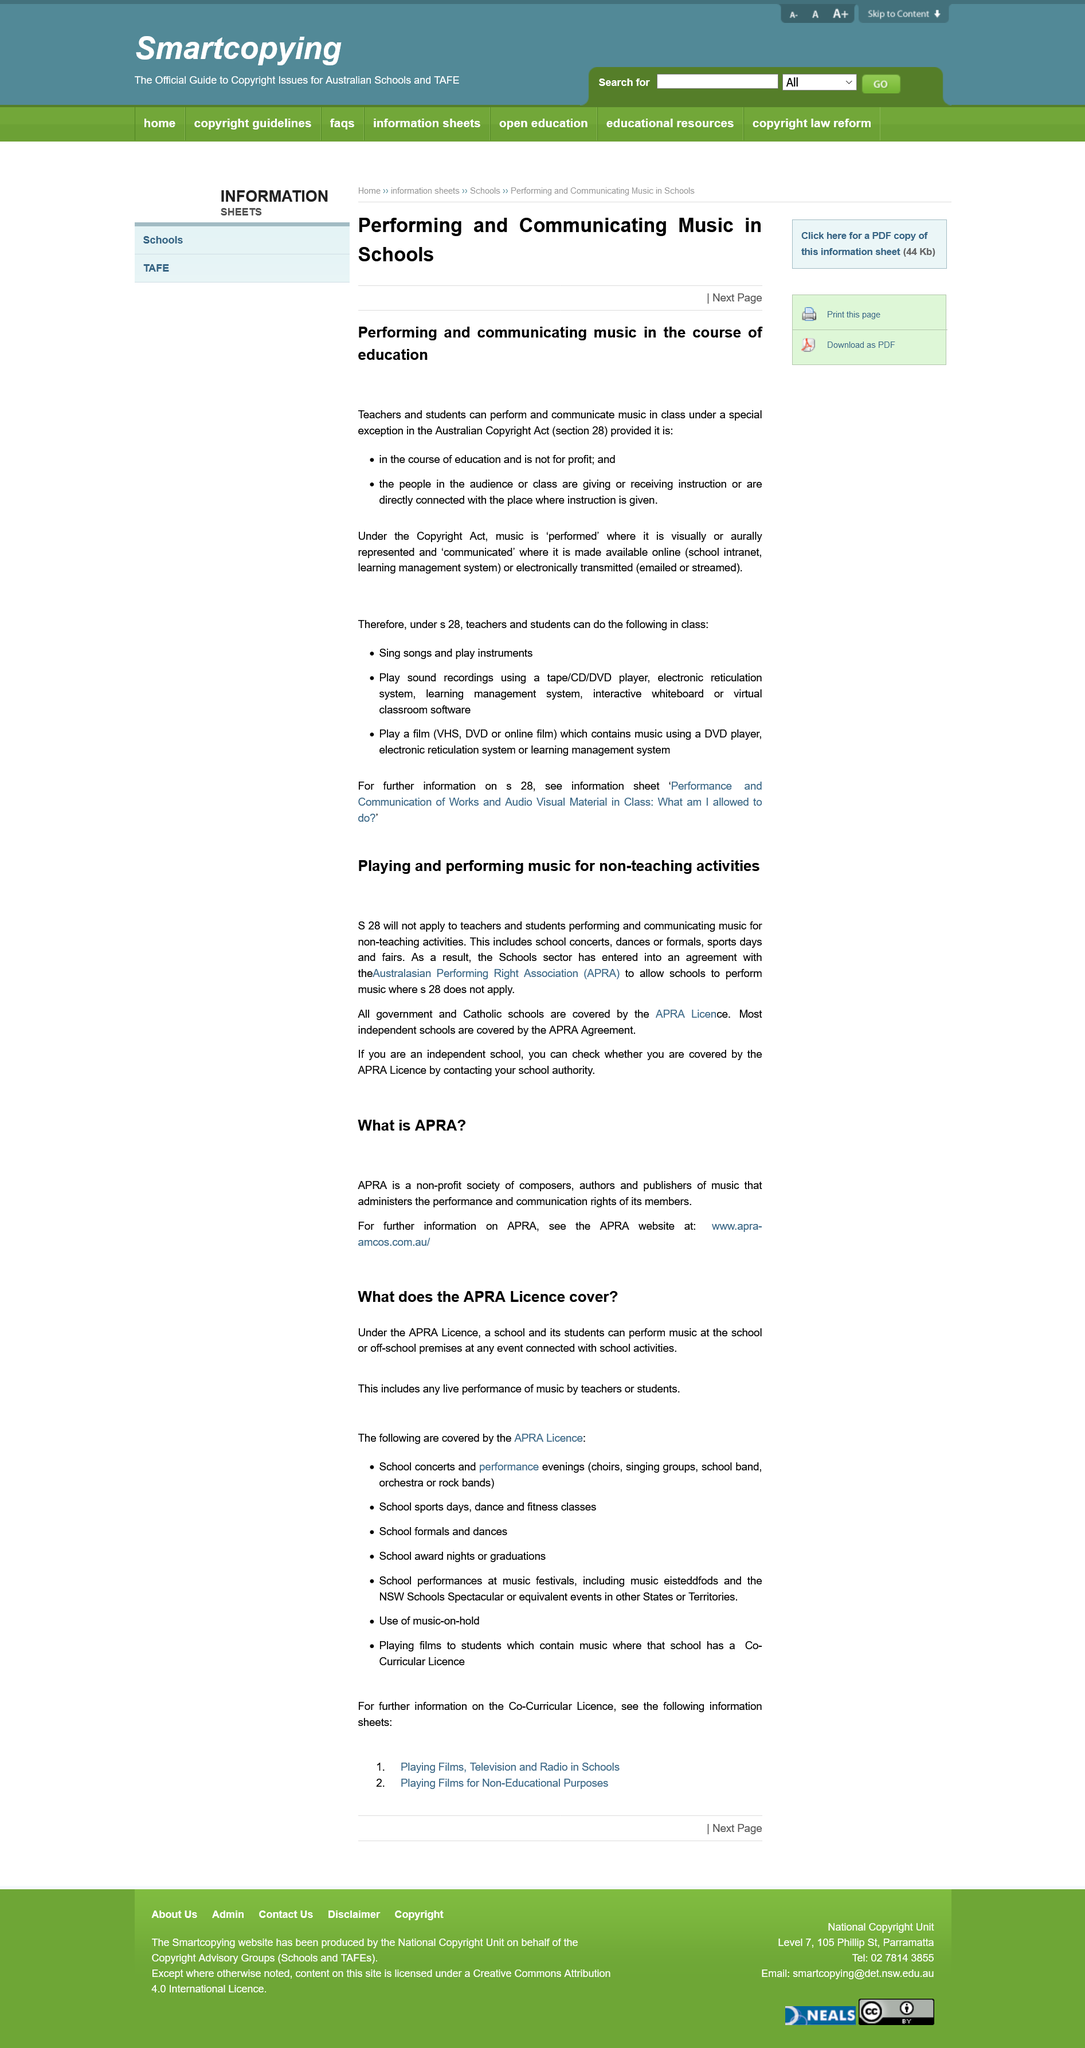Highlight a few significant elements in this photo. Yes, school graduation events are covered under the APRA License, which provides protection and coverage for such events. Members of ARPA include composers, authors, and publishers of music who are dedicated to promoting the rights and interests of professional and amateur performers of music in Canada. The article discusses the regulations for music education in Australia. Only teachers and students following the rules of the Australian Copyright Act section 28 are permitted to perform music in class in Australia. The APRA Licence is the only one that covers all government and Catholic schools. 